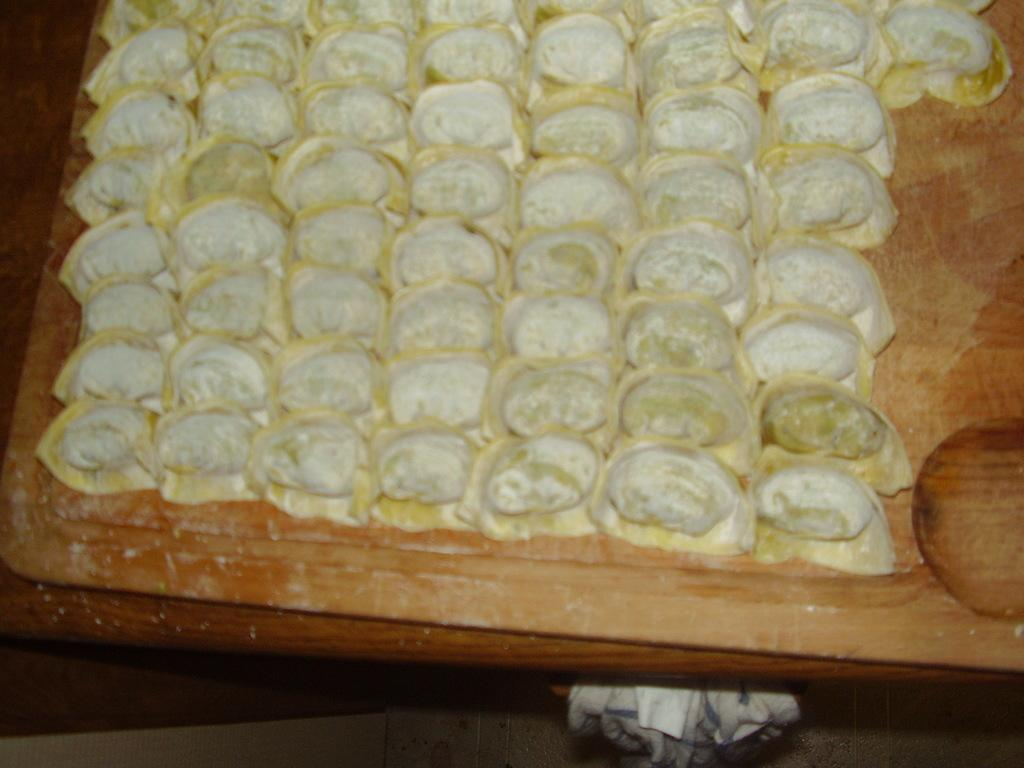What is the main subject of the image? There is a food item in the image. How is the food item presented? The food item is placed on a wooden board. What can be seen at the bottom of the image? There is a cloth visible at the bottom of the image. What type of vase is placed on the wooden board next to the food item? There is no vase present in the image; it only features a food item placed on a wooden board and a cloth visible at the bottom. 